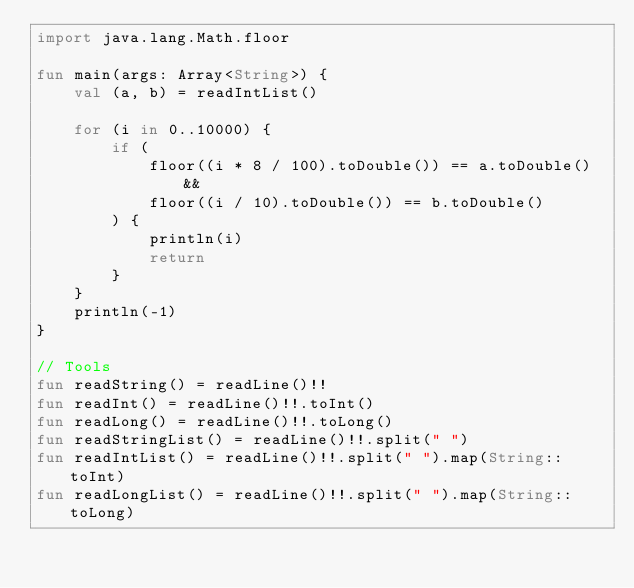<code> <loc_0><loc_0><loc_500><loc_500><_Kotlin_>import java.lang.Math.floor

fun main(args: Array<String>) {
    val (a, b) = readIntList()

    for (i in 0..10000) {
        if (
            floor((i * 8 / 100).toDouble()) == a.toDouble() &&
            floor((i / 10).toDouble()) == b.toDouble()
        ) {
            println(i)
            return
        }
    }
    println(-1)
}

// Tools
fun readString() = readLine()!!
fun readInt() = readLine()!!.toInt()
fun readLong() = readLine()!!.toLong()
fun readStringList() = readLine()!!.split(" ")
fun readIntList() = readLine()!!.split(" ").map(String::toInt)
fun readLongList() = readLine()!!.split(" ").map(String::toLong)
</code> 